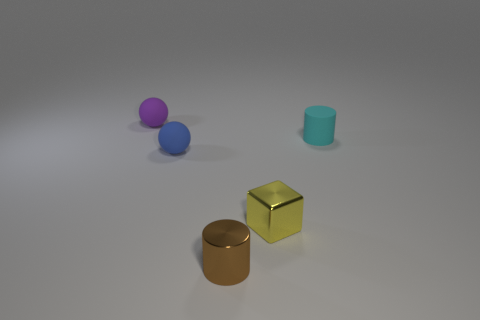Is the shape of the tiny metallic thing to the left of the small yellow metallic cube the same as the small matte object that is behind the small cyan cylinder?
Provide a short and direct response. No. Are there any large green objects made of the same material as the brown object?
Make the answer very short. No. What number of gray things are small matte cylinders or spheres?
Offer a very short reply. 0. What size is the rubber thing that is both to the right of the small purple matte ball and to the left of the small cyan rubber object?
Make the answer very short. Small. Are there more tiny objects that are left of the small cyan thing than matte spheres?
Offer a very short reply. Yes. What number of spheres are tiny purple rubber objects or brown metal objects?
Your answer should be compact. 1. What shape is the thing that is to the right of the blue rubber object and behind the small metal cube?
Your answer should be compact. Cylinder. Are there the same number of tiny rubber balls that are to the right of the blue thing and tiny blue balls on the left side of the small yellow metallic object?
Give a very brief answer. No. What number of objects are either small yellow metallic things or big gray blocks?
Your answer should be very brief. 1. There is a metal cube that is the same size as the brown cylinder; what is its color?
Your answer should be compact. Yellow. 